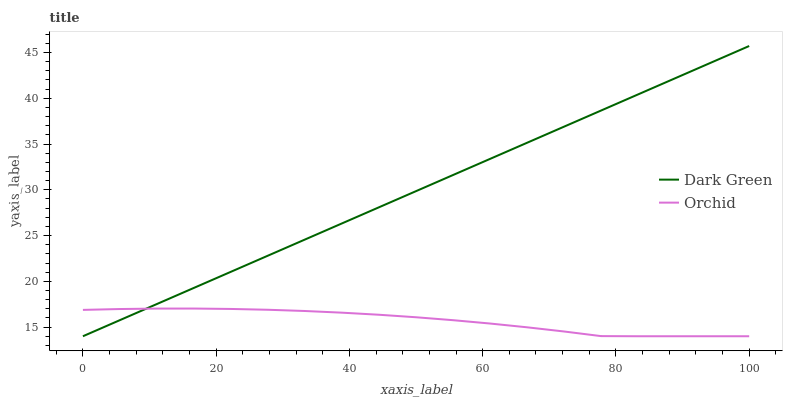Does Orchid have the minimum area under the curve?
Answer yes or no. Yes. Does Dark Green have the maximum area under the curve?
Answer yes or no. Yes. Does Dark Green have the minimum area under the curve?
Answer yes or no. No. Is Dark Green the smoothest?
Answer yes or no. Yes. Is Orchid the roughest?
Answer yes or no. Yes. Is Dark Green the roughest?
Answer yes or no. No. Does Orchid have the lowest value?
Answer yes or no. Yes. Does Dark Green have the highest value?
Answer yes or no. Yes. Does Orchid intersect Dark Green?
Answer yes or no. Yes. Is Orchid less than Dark Green?
Answer yes or no. No. Is Orchid greater than Dark Green?
Answer yes or no. No. 